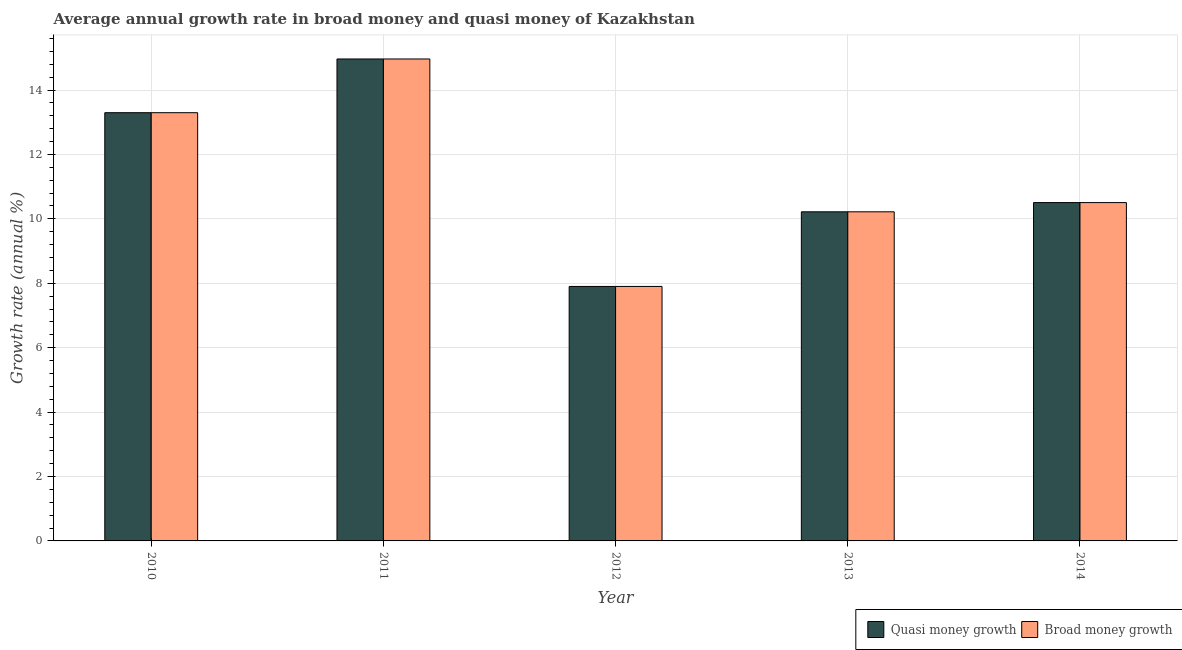How many different coloured bars are there?
Provide a short and direct response. 2. Are the number of bars on each tick of the X-axis equal?
Your answer should be very brief. Yes. How many bars are there on the 5th tick from the right?
Your answer should be very brief. 2. In how many cases, is the number of bars for a given year not equal to the number of legend labels?
Your answer should be compact. 0. What is the annual growth rate in quasi money in 2013?
Keep it short and to the point. 10.22. Across all years, what is the maximum annual growth rate in broad money?
Ensure brevity in your answer.  14.96. Across all years, what is the minimum annual growth rate in broad money?
Offer a terse response. 7.9. In which year was the annual growth rate in broad money minimum?
Give a very brief answer. 2012. What is the total annual growth rate in quasi money in the graph?
Your answer should be very brief. 56.89. What is the difference between the annual growth rate in broad money in 2010 and that in 2013?
Ensure brevity in your answer.  3.08. What is the difference between the annual growth rate in broad money in 2013 and the annual growth rate in quasi money in 2014?
Your answer should be very brief. -0.29. What is the average annual growth rate in quasi money per year?
Provide a short and direct response. 11.38. In the year 2010, what is the difference between the annual growth rate in quasi money and annual growth rate in broad money?
Keep it short and to the point. 0. What is the ratio of the annual growth rate in broad money in 2011 to that in 2014?
Give a very brief answer. 1.42. Is the annual growth rate in quasi money in 2010 less than that in 2013?
Offer a very short reply. No. What is the difference between the highest and the second highest annual growth rate in broad money?
Provide a succinct answer. 1.67. What is the difference between the highest and the lowest annual growth rate in broad money?
Provide a short and direct response. 7.06. In how many years, is the annual growth rate in quasi money greater than the average annual growth rate in quasi money taken over all years?
Keep it short and to the point. 2. Is the sum of the annual growth rate in quasi money in 2011 and 2013 greater than the maximum annual growth rate in broad money across all years?
Offer a very short reply. Yes. What does the 1st bar from the left in 2014 represents?
Offer a terse response. Quasi money growth. What does the 1st bar from the right in 2011 represents?
Give a very brief answer. Broad money growth. How many bars are there?
Provide a short and direct response. 10. How many years are there in the graph?
Make the answer very short. 5. Where does the legend appear in the graph?
Provide a succinct answer. Bottom right. What is the title of the graph?
Ensure brevity in your answer.  Average annual growth rate in broad money and quasi money of Kazakhstan. What is the label or title of the X-axis?
Ensure brevity in your answer.  Year. What is the label or title of the Y-axis?
Offer a terse response. Growth rate (annual %). What is the Growth rate (annual %) in Quasi money growth in 2010?
Give a very brief answer. 13.3. What is the Growth rate (annual %) in Broad money growth in 2010?
Your answer should be compact. 13.3. What is the Growth rate (annual %) in Quasi money growth in 2011?
Your response must be concise. 14.96. What is the Growth rate (annual %) of Broad money growth in 2011?
Ensure brevity in your answer.  14.96. What is the Growth rate (annual %) of Quasi money growth in 2012?
Your answer should be compact. 7.9. What is the Growth rate (annual %) in Broad money growth in 2012?
Your answer should be very brief. 7.9. What is the Growth rate (annual %) in Quasi money growth in 2013?
Your response must be concise. 10.22. What is the Growth rate (annual %) of Broad money growth in 2013?
Make the answer very short. 10.22. What is the Growth rate (annual %) in Quasi money growth in 2014?
Your answer should be compact. 10.51. What is the Growth rate (annual %) in Broad money growth in 2014?
Your answer should be very brief. 10.51. Across all years, what is the maximum Growth rate (annual %) in Quasi money growth?
Provide a succinct answer. 14.96. Across all years, what is the maximum Growth rate (annual %) in Broad money growth?
Ensure brevity in your answer.  14.96. Across all years, what is the minimum Growth rate (annual %) of Quasi money growth?
Your answer should be very brief. 7.9. Across all years, what is the minimum Growth rate (annual %) of Broad money growth?
Ensure brevity in your answer.  7.9. What is the total Growth rate (annual %) in Quasi money growth in the graph?
Ensure brevity in your answer.  56.89. What is the total Growth rate (annual %) in Broad money growth in the graph?
Offer a very short reply. 56.89. What is the difference between the Growth rate (annual %) in Quasi money growth in 2010 and that in 2011?
Your response must be concise. -1.67. What is the difference between the Growth rate (annual %) in Broad money growth in 2010 and that in 2011?
Provide a short and direct response. -1.67. What is the difference between the Growth rate (annual %) in Quasi money growth in 2010 and that in 2012?
Offer a terse response. 5.39. What is the difference between the Growth rate (annual %) of Broad money growth in 2010 and that in 2012?
Provide a short and direct response. 5.39. What is the difference between the Growth rate (annual %) of Quasi money growth in 2010 and that in 2013?
Keep it short and to the point. 3.08. What is the difference between the Growth rate (annual %) in Broad money growth in 2010 and that in 2013?
Ensure brevity in your answer.  3.08. What is the difference between the Growth rate (annual %) of Quasi money growth in 2010 and that in 2014?
Give a very brief answer. 2.79. What is the difference between the Growth rate (annual %) in Broad money growth in 2010 and that in 2014?
Your answer should be compact. 2.79. What is the difference between the Growth rate (annual %) in Quasi money growth in 2011 and that in 2012?
Give a very brief answer. 7.06. What is the difference between the Growth rate (annual %) in Broad money growth in 2011 and that in 2012?
Offer a terse response. 7.06. What is the difference between the Growth rate (annual %) of Quasi money growth in 2011 and that in 2013?
Give a very brief answer. 4.75. What is the difference between the Growth rate (annual %) of Broad money growth in 2011 and that in 2013?
Your response must be concise. 4.75. What is the difference between the Growth rate (annual %) of Quasi money growth in 2011 and that in 2014?
Provide a short and direct response. 4.46. What is the difference between the Growth rate (annual %) in Broad money growth in 2011 and that in 2014?
Offer a terse response. 4.46. What is the difference between the Growth rate (annual %) of Quasi money growth in 2012 and that in 2013?
Your answer should be very brief. -2.32. What is the difference between the Growth rate (annual %) in Broad money growth in 2012 and that in 2013?
Make the answer very short. -2.32. What is the difference between the Growth rate (annual %) in Quasi money growth in 2012 and that in 2014?
Keep it short and to the point. -2.6. What is the difference between the Growth rate (annual %) in Broad money growth in 2012 and that in 2014?
Offer a terse response. -2.6. What is the difference between the Growth rate (annual %) in Quasi money growth in 2013 and that in 2014?
Your response must be concise. -0.29. What is the difference between the Growth rate (annual %) of Broad money growth in 2013 and that in 2014?
Make the answer very short. -0.29. What is the difference between the Growth rate (annual %) of Quasi money growth in 2010 and the Growth rate (annual %) of Broad money growth in 2011?
Provide a succinct answer. -1.67. What is the difference between the Growth rate (annual %) of Quasi money growth in 2010 and the Growth rate (annual %) of Broad money growth in 2012?
Your answer should be very brief. 5.39. What is the difference between the Growth rate (annual %) in Quasi money growth in 2010 and the Growth rate (annual %) in Broad money growth in 2013?
Provide a succinct answer. 3.08. What is the difference between the Growth rate (annual %) of Quasi money growth in 2010 and the Growth rate (annual %) of Broad money growth in 2014?
Provide a succinct answer. 2.79. What is the difference between the Growth rate (annual %) of Quasi money growth in 2011 and the Growth rate (annual %) of Broad money growth in 2012?
Make the answer very short. 7.06. What is the difference between the Growth rate (annual %) of Quasi money growth in 2011 and the Growth rate (annual %) of Broad money growth in 2013?
Offer a terse response. 4.75. What is the difference between the Growth rate (annual %) of Quasi money growth in 2011 and the Growth rate (annual %) of Broad money growth in 2014?
Your answer should be compact. 4.46. What is the difference between the Growth rate (annual %) in Quasi money growth in 2012 and the Growth rate (annual %) in Broad money growth in 2013?
Offer a very short reply. -2.32. What is the difference between the Growth rate (annual %) in Quasi money growth in 2012 and the Growth rate (annual %) in Broad money growth in 2014?
Your answer should be very brief. -2.6. What is the difference between the Growth rate (annual %) of Quasi money growth in 2013 and the Growth rate (annual %) of Broad money growth in 2014?
Ensure brevity in your answer.  -0.29. What is the average Growth rate (annual %) of Quasi money growth per year?
Provide a succinct answer. 11.38. What is the average Growth rate (annual %) in Broad money growth per year?
Provide a succinct answer. 11.38. In the year 2011, what is the difference between the Growth rate (annual %) of Quasi money growth and Growth rate (annual %) of Broad money growth?
Keep it short and to the point. 0. In the year 2013, what is the difference between the Growth rate (annual %) of Quasi money growth and Growth rate (annual %) of Broad money growth?
Provide a short and direct response. 0. In the year 2014, what is the difference between the Growth rate (annual %) in Quasi money growth and Growth rate (annual %) in Broad money growth?
Offer a terse response. 0. What is the ratio of the Growth rate (annual %) in Quasi money growth in 2010 to that in 2011?
Offer a terse response. 0.89. What is the ratio of the Growth rate (annual %) in Broad money growth in 2010 to that in 2011?
Ensure brevity in your answer.  0.89. What is the ratio of the Growth rate (annual %) in Quasi money growth in 2010 to that in 2012?
Your answer should be very brief. 1.68. What is the ratio of the Growth rate (annual %) in Broad money growth in 2010 to that in 2012?
Keep it short and to the point. 1.68. What is the ratio of the Growth rate (annual %) in Quasi money growth in 2010 to that in 2013?
Ensure brevity in your answer.  1.3. What is the ratio of the Growth rate (annual %) in Broad money growth in 2010 to that in 2013?
Your answer should be very brief. 1.3. What is the ratio of the Growth rate (annual %) of Quasi money growth in 2010 to that in 2014?
Keep it short and to the point. 1.27. What is the ratio of the Growth rate (annual %) of Broad money growth in 2010 to that in 2014?
Ensure brevity in your answer.  1.27. What is the ratio of the Growth rate (annual %) in Quasi money growth in 2011 to that in 2012?
Provide a short and direct response. 1.89. What is the ratio of the Growth rate (annual %) in Broad money growth in 2011 to that in 2012?
Keep it short and to the point. 1.89. What is the ratio of the Growth rate (annual %) of Quasi money growth in 2011 to that in 2013?
Offer a terse response. 1.46. What is the ratio of the Growth rate (annual %) in Broad money growth in 2011 to that in 2013?
Your answer should be very brief. 1.46. What is the ratio of the Growth rate (annual %) of Quasi money growth in 2011 to that in 2014?
Ensure brevity in your answer.  1.42. What is the ratio of the Growth rate (annual %) in Broad money growth in 2011 to that in 2014?
Give a very brief answer. 1.42. What is the ratio of the Growth rate (annual %) of Quasi money growth in 2012 to that in 2013?
Ensure brevity in your answer.  0.77. What is the ratio of the Growth rate (annual %) in Broad money growth in 2012 to that in 2013?
Offer a very short reply. 0.77. What is the ratio of the Growth rate (annual %) in Quasi money growth in 2012 to that in 2014?
Provide a succinct answer. 0.75. What is the ratio of the Growth rate (annual %) of Broad money growth in 2012 to that in 2014?
Give a very brief answer. 0.75. What is the ratio of the Growth rate (annual %) of Quasi money growth in 2013 to that in 2014?
Provide a succinct answer. 0.97. What is the ratio of the Growth rate (annual %) in Broad money growth in 2013 to that in 2014?
Give a very brief answer. 0.97. What is the difference between the highest and the second highest Growth rate (annual %) in Quasi money growth?
Provide a short and direct response. 1.67. What is the difference between the highest and the second highest Growth rate (annual %) of Broad money growth?
Provide a short and direct response. 1.67. What is the difference between the highest and the lowest Growth rate (annual %) in Quasi money growth?
Give a very brief answer. 7.06. What is the difference between the highest and the lowest Growth rate (annual %) of Broad money growth?
Offer a very short reply. 7.06. 